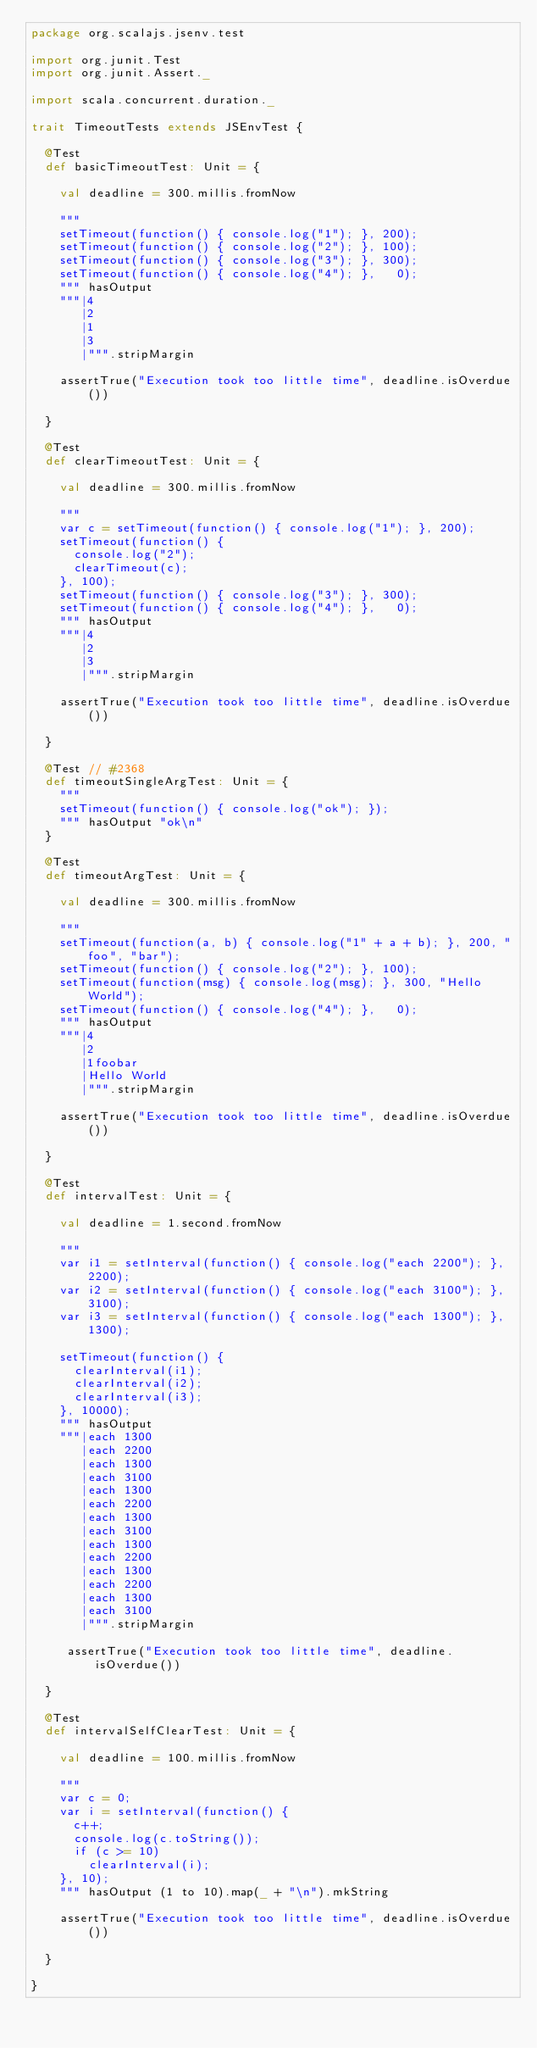Convert code to text. <code><loc_0><loc_0><loc_500><loc_500><_Scala_>package org.scalajs.jsenv.test

import org.junit.Test
import org.junit.Assert._

import scala.concurrent.duration._

trait TimeoutTests extends JSEnvTest {

  @Test
  def basicTimeoutTest: Unit = {

    val deadline = 300.millis.fromNow

    """
    setTimeout(function() { console.log("1"); }, 200);
    setTimeout(function() { console.log("2"); }, 100);
    setTimeout(function() { console.log("3"); }, 300);
    setTimeout(function() { console.log("4"); },   0);
    """ hasOutput
    """|4
       |2
       |1
       |3
       |""".stripMargin

    assertTrue("Execution took too little time", deadline.isOverdue())

  }

  @Test
  def clearTimeoutTest: Unit = {

    val deadline = 300.millis.fromNow

    """
    var c = setTimeout(function() { console.log("1"); }, 200);
    setTimeout(function() {
      console.log("2");
      clearTimeout(c);
    }, 100);
    setTimeout(function() { console.log("3"); }, 300);
    setTimeout(function() { console.log("4"); },   0);
    """ hasOutput
    """|4
       |2
       |3
       |""".stripMargin

    assertTrue("Execution took too little time", deadline.isOverdue())

  }

  @Test // #2368
  def timeoutSingleArgTest: Unit = {
    """
    setTimeout(function() { console.log("ok"); });
    """ hasOutput "ok\n"
  }

  @Test
  def timeoutArgTest: Unit = {

    val deadline = 300.millis.fromNow

    """
    setTimeout(function(a, b) { console.log("1" + a + b); }, 200, "foo", "bar");
    setTimeout(function() { console.log("2"); }, 100);
    setTimeout(function(msg) { console.log(msg); }, 300, "Hello World");
    setTimeout(function() { console.log("4"); },   0);
    """ hasOutput
    """|4
       |2
       |1foobar
       |Hello World
       |""".stripMargin

    assertTrue("Execution took too little time", deadline.isOverdue())

  }

  @Test
  def intervalTest: Unit = {

    val deadline = 1.second.fromNow

    """
    var i1 = setInterval(function() { console.log("each 2200"); }, 2200);
    var i2 = setInterval(function() { console.log("each 3100"); }, 3100);
    var i3 = setInterval(function() { console.log("each 1300"); }, 1300);

    setTimeout(function() {
      clearInterval(i1);
      clearInterval(i2);
      clearInterval(i3);
    }, 10000);
    """ hasOutput
    """|each 1300
       |each 2200
       |each 1300
       |each 3100
       |each 1300
       |each 2200
       |each 1300
       |each 3100
       |each 1300
       |each 2200
       |each 1300
       |each 2200
       |each 1300
       |each 3100
       |""".stripMargin

     assertTrue("Execution took too little time", deadline.isOverdue())

  }

  @Test
  def intervalSelfClearTest: Unit = {

    val deadline = 100.millis.fromNow

    """
    var c = 0;
    var i = setInterval(function() {
      c++;
      console.log(c.toString());
      if (c >= 10)
        clearInterval(i);
    }, 10);
    """ hasOutput (1 to 10).map(_ + "\n").mkString

    assertTrue("Execution took too little time", deadline.isOverdue())

  }

}
</code> 